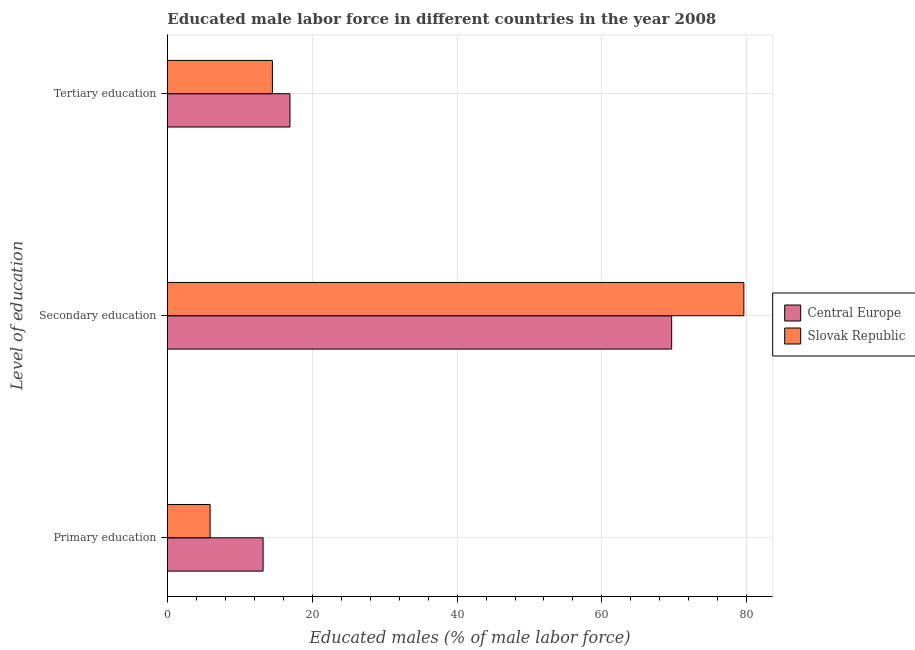How many groups of bars are there?
Your answer should be very brief. 3. Are the number of bars per tick equal to the number of legend labels?
Offer a very short reply. Yes. Are the number of bars on each tick of the Y-axis equal?
Keep it short and to the point. Yes. How many bars are there on the 1st tick from the top?
Make the answer very short. 2. What is the label of the 1st group of bars from the top?
Provide a succinct answer. Tertiary education. What is the percentage of male labor force who received secondary education in Central Europe?
Offer a very short reply. 69.63. Across all countries, what is the maximum percentage of male labor force who received secondary education?
Your response must be concise. 79.6. Across all countries, what is the minimum percentage of male labor force who received primary education?
Your answer should be very brief. 5.9. In which country was the percentage of male labor force who received secondary education maximum?
Keep it short and to the point. Slovak Republic. In which country was the percentage of male labor force who received secondary education minimum?
Ensure brevity in your answer.  Central Europe. What is the total percentage of male labor force who received secondary education in the graph?
Your answer should be very brief. 149.23. What is the difference between the percentage of male labor force who received secondary education in Slovak Republic and that in Central Europe?
Ensure brevity in your answer.  9.97. What is the difference between the percentage of male labor force who received tertiary education in Slovak Republic and the percentage of male labor force who received secondary education in Central Europe?
Offer a very short reply. -55.13. What is the average percentage of male labor force who received tertiary education per country?
Give a very brief answer. 15.71. What is the difference between the percentage of male labor force who received primary education and percentage of male labor force who received tertiary education in Central Europe?
Ensure brevity in your answer.  -3.71. In how many countries, is the percentage of male labor force who received tertiary education greater than 76 %?
Ensure brevity in your answer.  0. What is the ratio of the percentage of male labor force who received secondary education in Slovak Republic to that in Central Europe?
Your answer should be very brief. 1.14. Is the difference between the percentage of male labor force who received secondary education in Slovak Republic and Central Europe greater than the difference between the percentage of male labor force who received primary education in Slovak Republic and Central Europe?
Your answer should be very brief. Yes. What is the difference between the highest and the second highest percentage of male labor force who received tertiary education?
Offer a terse response. 2.43. What is the difference between the highest and the lowest percentage of male labor force who received secondary education?
Provide a succinct answer. 9.97. In how many countries, is the percentage of male labor force who received primary education greater than the average percentage of male labor force who received primary education taken over all countries?
Provide a succinct answer. 1. What does the 1st bar from the top in Secondary education represents?
Ensure brevity in your answer.  Slovak Republic. What does the 1st bar from the bottom in Primary education represents?
Offer a very short reply. Central Europe. How many bars are there?
Ensure brevity in your answer.  6. Does the graph contain any zero values?
Offer a very short reply. No. Does the graph contain grids?
Your answer should be compact. Yes. How are the legend labels stacked?
Offer a very short reply. Vertical. What is the title of the graph?
Give a very brief answer. Educated male labor force in different countries in the year 2008. What is the label or title of the X-axis?
Your answer should be compact. Educated males (% of male labor force). What is the label or title of the Y-axis?
Make the answer very short. Level of education. What is the Educated males (% of male labor force) of Central Europe in Primary education?
Provide a succinct answer. 13.22. What is the Educated males (% of male labor force) in Slovak Republic in Primary education?
Offer a very short reply. 5.9. What is the Educated males (% of male labor force) in Central Europe in Secondary education?
Your answer should be compact. 69.63. What is the Educated males (% of male labor force) of Slovak Republic in Secondary education?
Make the answer very short. 79.6. What is the Educated males (% of male labor force) of Central Europe in Tertiary education?
Give a very brief answer. 16.93. Across all Level of education, what is the maximum Educated males (% of male labor force) of Central Europe?
Make the answer very short. 69.63. Across all Level of education, what is the maximum Educated males (% of male labor force) of Slovak Republic?
Provide a succinct answer. 79.6. Across all Level of education, what is the minimum Educated males (% of male labor force) in Central Europe?
Provide a succinct answer. 13.22. Across all Level of education, what is the minimum Educated males (% of male labor force) in Slovak Republic?
Keep it short and to the point. 5.9. What is the total Educated males (% of male labor force) of Central Europe in the graph?
Keep it short and to the point. 99.77. What is the difference between the Educated males (% of male labor force) of Central Europe in Primary education and that in Secondary education?
Provide a short and direct response. -56.42. What is the difference between the Educated males (% of male labor force) of Slovak Republic in Primary education and that in Secondary education?
Your answer should be very brief. -73.7. What is the difference between the Educated males (% of male labor force) of Central Europe in Primary education and that in Tertiary education?
Ensure brevity in your answer.  -3.71. What is the difference between the Educated males (% of male labor force) in Central Europe in Secondary education and that in Tertiary education?
Your response must be concise. 52.71. What is the difference between the Educated males (% of male labor force) of Slovak Republic in Secondary education and that in Tertiary education?
Provide a succinct answer. 65.1. What is the difference between the Educated males (% of male labor force) in Central Europe in Primary education and the Educated males (% of male labor force) in Slovak Republic in Secondary education?
Give a very brief answer. -66.38. What is the difference between the Educated males (% of male labor force) in Central Europe in Primary education and the Educated males (% of male labor force) in Slovak Republic in Tertiary education?
Provide a short and direct response. -1.28. What is the difference between the Educated males (% of male labor force) in Central Europe in Secondary education and the Educated males (% of male labor force) in Slovak Republic in Tertiary education?
Provide a succinct answer. 55.13. What is the average Educated males (% of male labor force) of Central Europe per Level of education?
Your answer should be very brief. 33.26. What is the average Educated males (% of male labor force) of Slovak Republic per Level of education?
Make the answer very short. 33.33. What is the difference between the Educated males (% of male labor force) in Central Europe and Educated males (% of male labor force) in Slovak Republic in Primary education?
Ensure brevity in your answer.  7.32. What is the difference between the Educated males (% of male labor force) of Central Europe and Educated males (% of male labor force) of Slovak Republic in Secondary education?
Offer a terse response. -9.97. What is the difference between the Educated males (% of male labor force) in Central Europe and Educated males (% of male labor force) in Slovak Republic in Tertiary education?
Give a very brief answer. 2.43. What is the ratio of the Educated males (% of male labor force) in Central Europe in Primary education to that in Secondary education?
Give a very brief answer. 0.19. What is the ratio of the Educated males (% of male labor force) in Slovak Republic in Primary education to that in Secondary education?
Provide a short and direct response. 0.07. What is the ratio of the Educated males (% of male labor force) of Central Europe in Primary education to that in Tertiary education?
Ensure brevity in your answer.  0.78. What is the ratio of the Educated males (% of male labor force) in Slovak Republic in Primary education to that in Tertiary education?
Provide a succinct answer. 0.41. What is the ratio of the Educated males (% of male labor force) in Central Europe in Secondary education to that in Tertiary education?
Give a very brief answer. 4.11. What is the ratio of the Educated males (% of male labor force) in Slovak Republic in Secondary education to that in Tertiary education?
Ensure brevity in your answer.  5.49. What is the difference between the highest and the second highest Educated males (% of male labor force) of Central Europe?
Your answer should be very brief. 52.71. What is the difference between the highest and the second highest Educated males (% of male labor force) in Slovak Republic?
Provide a succinct answer. 65.1. What is the difference between the highest and the lowest Educated males (% of male labor force) of Central Europe?
Make the answer very short. 56.42. What is the difference between the highest and the lowest Educated males (% of male labor force) of Slovak Republic?
Your answer should be very brief. 73.7. 